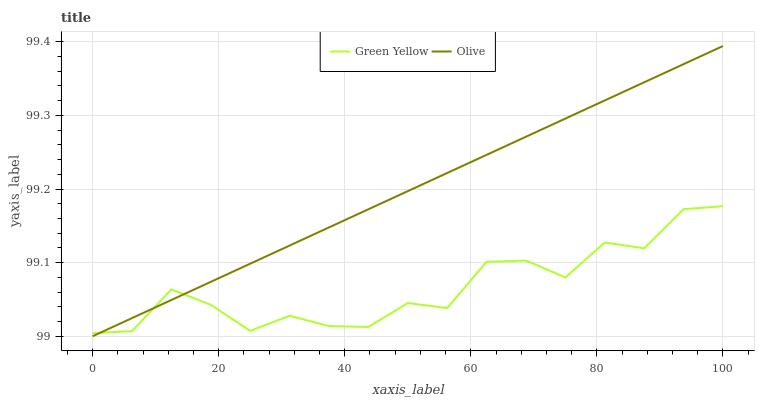Does Green Yellow have the minimum area under the curve?
Answer yes or no. Yes. Does Olive have the maximum area under the curve?
Answer yes or no. Yes. Does Green Yellow have the maximum area under the curve?
Answer yes or no. No. Is Olive the smoothest?
Answer yes or no. Yes. Is Green Yellow the roughest?
Answer yes or no. Yes. Is Green Yellow the smoothest?
Answer yes or no. No. Does Green Yellow have the lowest value?
Answer yes or no. No. Does Green Yellow have the highest value?
Answer yes or no. No. 